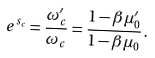Convert formula to latex. <formula><loc_0><loc_0><loc_500><loc_500>e ^ { s _ { c } } = \frac { \omega _ { c } ^ { \prime } } { \omega _ { c } } = \frac { 1 - \beta \mu _ { 0 } ^ { \prime } } { 1 - \beta \mu _ { 0 } } \, .</formula> 